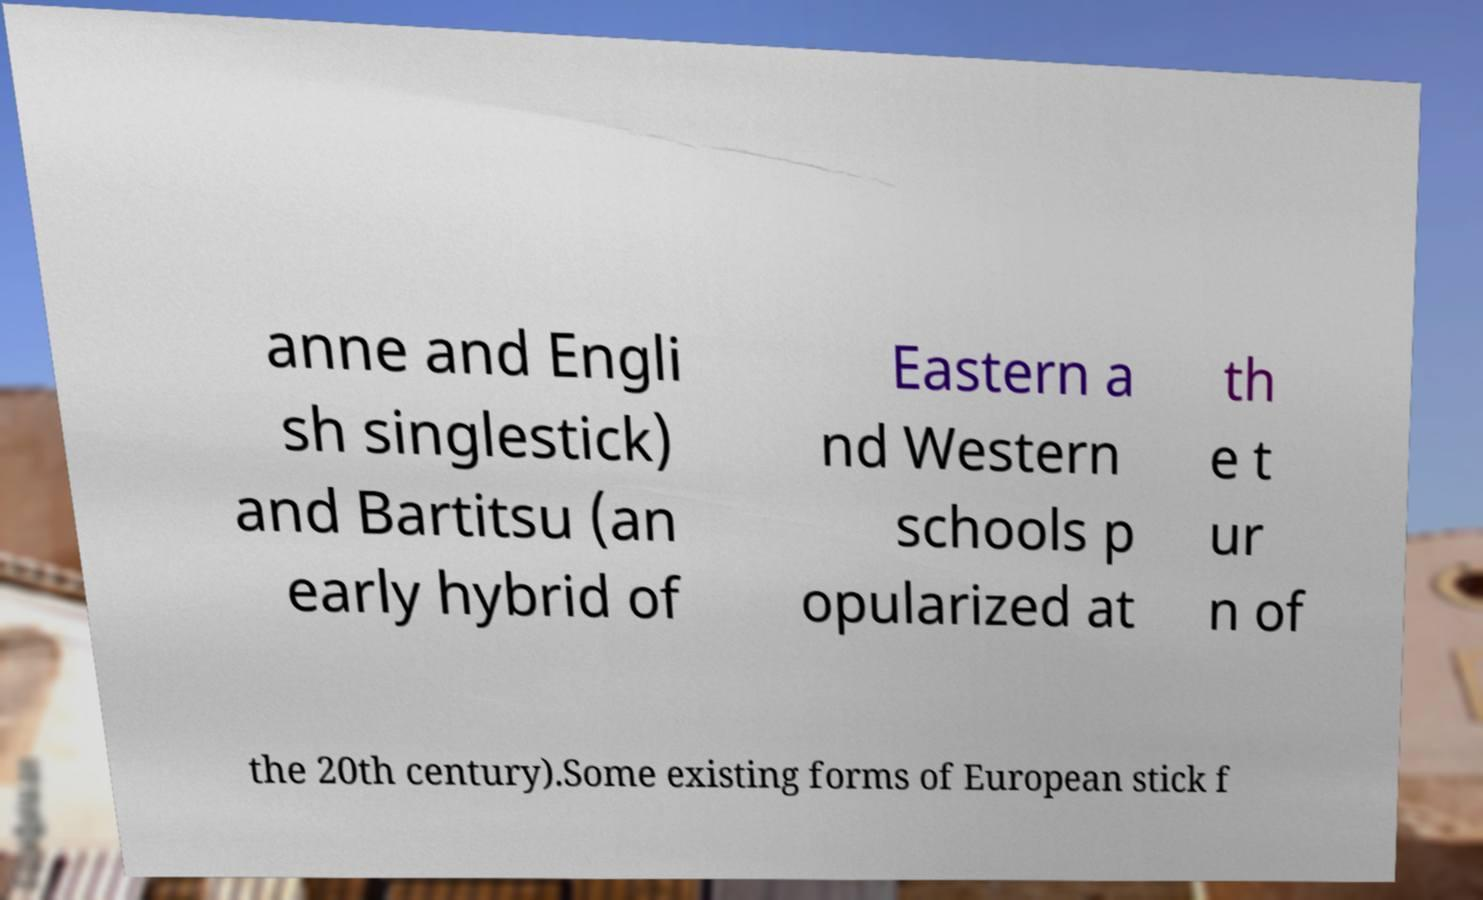There's text embedded in this image that I need extracted. Can you transcribe it verbatim? anne and Engli sh singlestick) and Bartitsu (an early hybrid of Eastern a nd Western schools p opularized at th e t ur n of the 20th century).Some existing forms of European stick f 